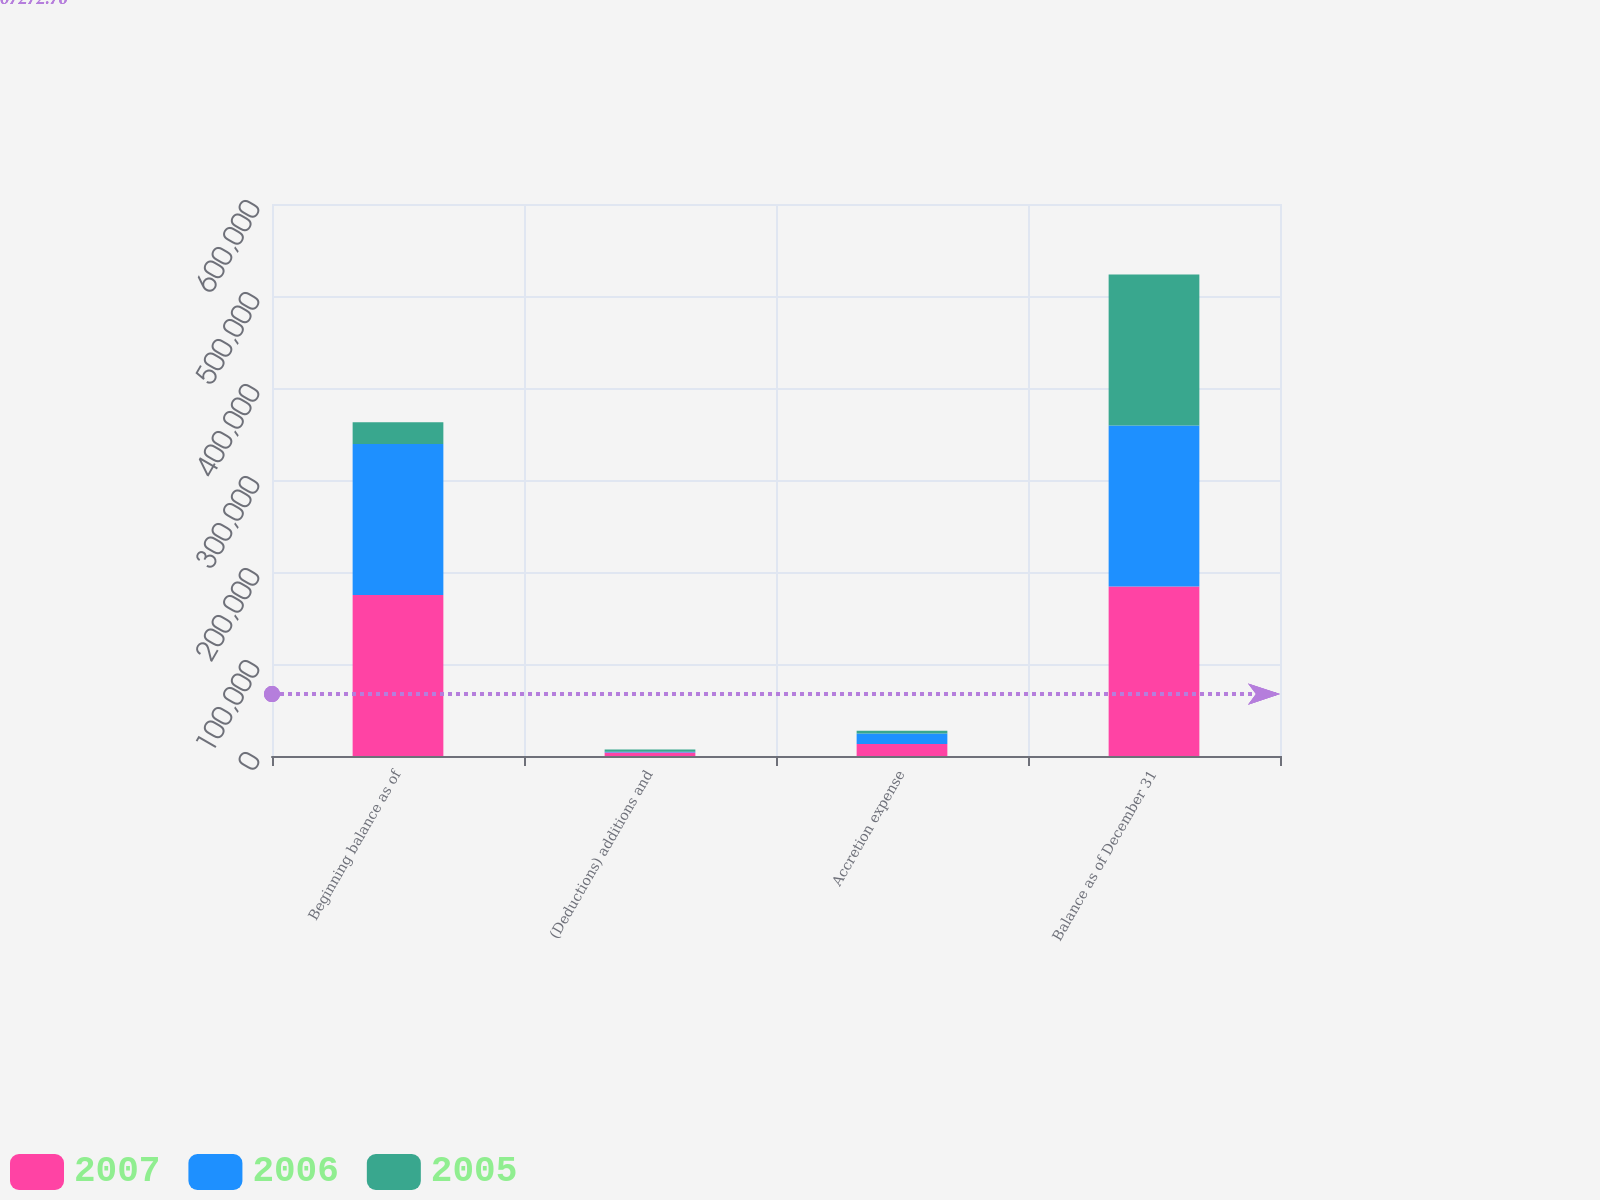Convert chart to OTSL. <chart><loc_0><loc_0><loc_500><loc_500><stacked_bar_chart><ecel><fcel>Beginning balance as of<fcel>(Deductions) additions and<fcel>Accretion expense<fcel>Balance as of December 31<nl><fcel>2007<fcel>174980<fcel>3776<fcel>12958<fcel>184162<nl><fcel>2006<fcel>164222<fcel>710<fcel>11468<fcel>174980<nl><fcel>2005<fcel>23464<fcel>2587<fcel>3069<fcel>164222<nl></chart> 